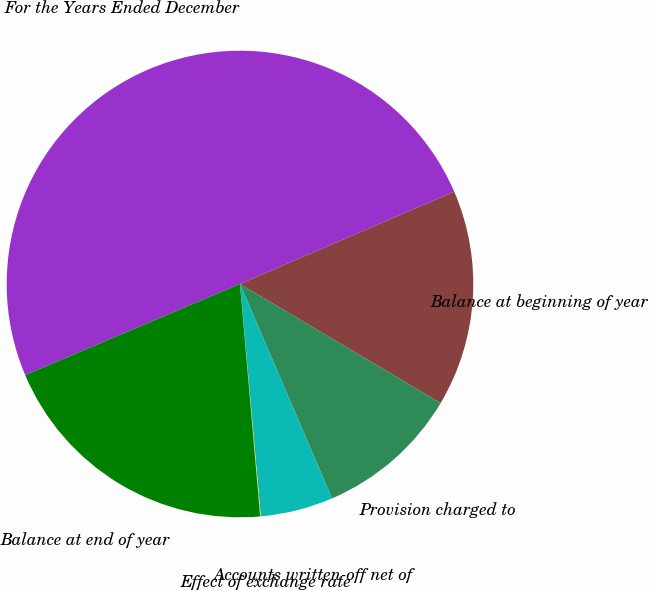<chart> <loc_0><loc_0><loc_500><loc_500><pie_chart><fcel>For the Years Ended December<fcel>Balance at beginning of year<fcel>Provision charged to<fcel>Accounts written-off net of<fcel>Effect of exchange rate<fcel>Balance at end of year<nl><fcel>49.9%<fcel>15.0%<fcel>10.02%<fcel>5.03%<fcel>0.05%<fcel>19.99%<nl></chart> 